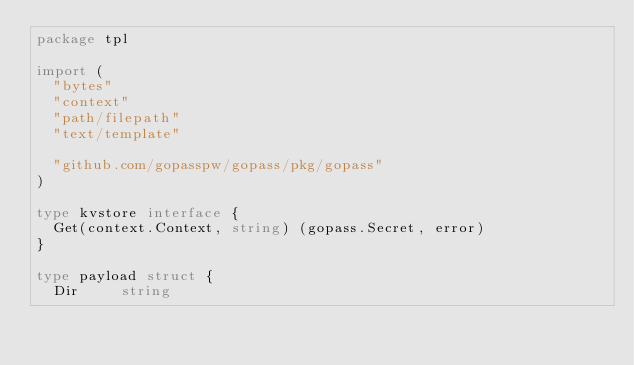Convert code to text. <code><loc_0><loc_0><loc_500><loc_500><_Go_>package tpl

import (
	"bytes"
	"context"
	"path/filepath"
	"text/template"

	"github.com/gopasspw/gopass/pkg/gopass"
)

type kvstore interface {
	Get(context.Context, string) (gopass.Secret, error)
}

type payload struct {
	Dir     string</code> 